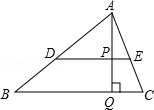Clarify your interpretation of the image. In the diagram, there is a triangle labeled ABC, with vertices A, B, and C. There's a line DE that runs parallel to the line BC. The point Q is where line AQ intersects line BC, and line AQ is perpendicular to line BC. The point P is where line AQ intersects line DE. Points A and D are connected, as well as points B and D. 